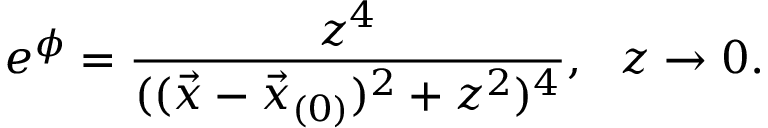Convert formula to latex. <formula><loc_0><loc_0><loc_500><loc_500>e ^ { \phi } = { \frac { z ^ { 4 } } { ( ( \vec { x } - \vec { x } _ { ( 0 ) } ) ^ { 2 } + z ^ { 2 } ) ^ { 4 } } } , \ \ z \rightarrow 0 .</formula> 